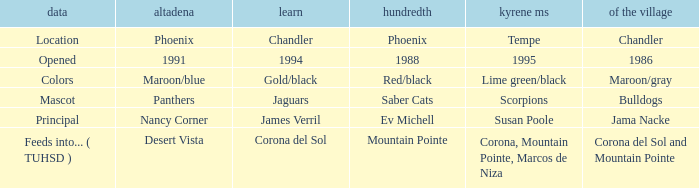WHich kind of Aprende has a Centennial of 1988? 1994.0. 